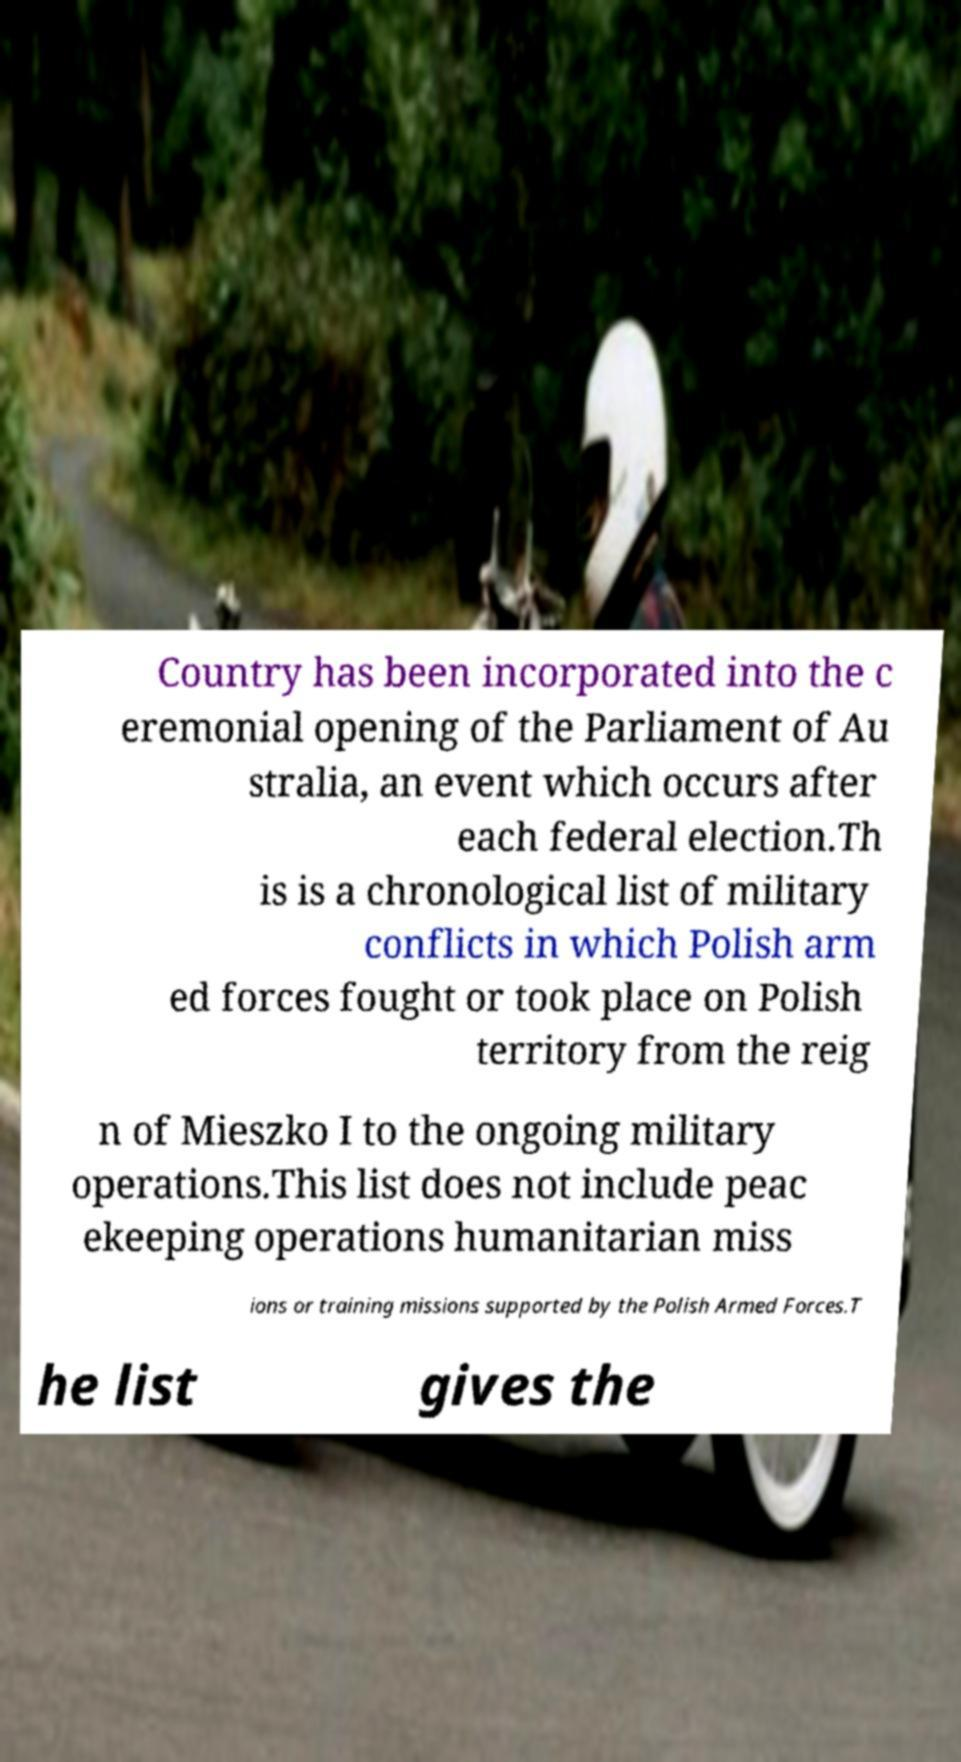There's text embedded in this image that I need extracted. Can you transcribe it verbatim? Country has been incorporated into the c eremonial opening of the Parliament of Au stralia, an event which occurs after each federal election.Th is is a chronological list of military conflicts in which Polish arm ed forces fought or took place on Polish territory from the reig n of Mieszko I to the ongoing military operations.This list does not include peac ekeeping operations humanitarian miss ions or training missions supported by the Polish Armed Forces.T he list gives the 